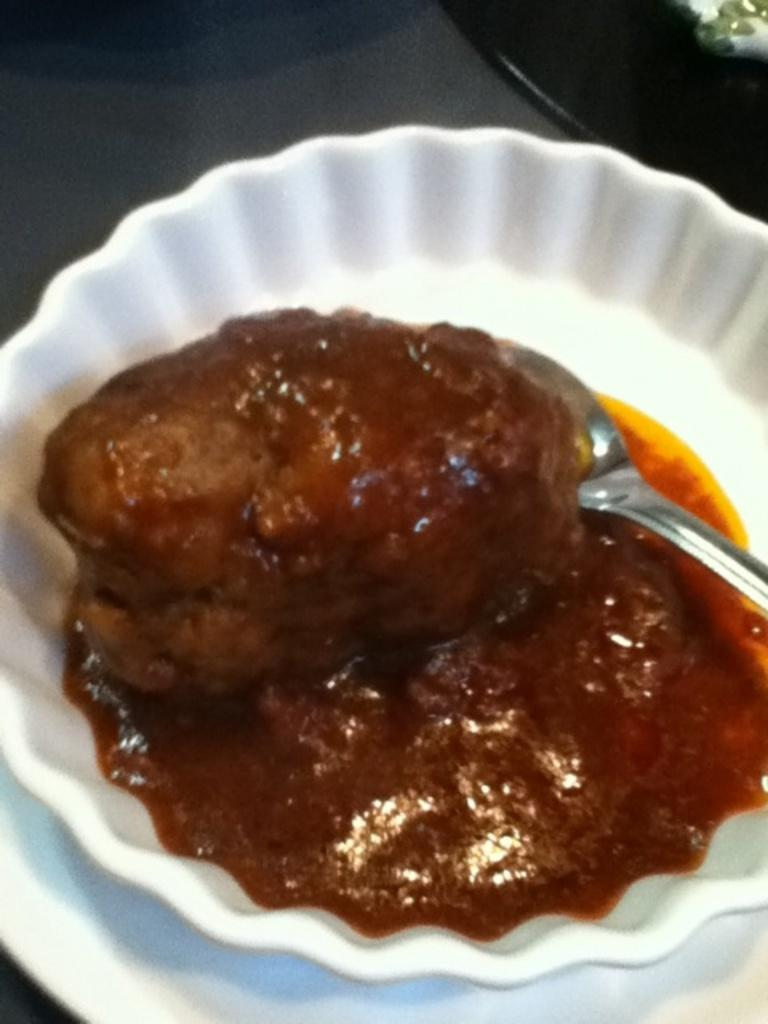What is on the plate in the image? There is a bowl on a plate in the image. What is inside the bowl? The bowl contains a food item. What utensil is present in the image? There is a spoon in the image. Can you describe the object in the top right corner of the image? Unfortunately, the facts provided do not give enough information to describe the object in the top right corner of the image. How does the detail in the image rub against the hammer? There is no detail rubbing against a hammer in the image, as the facts provided do not mention a hammer or any rubbing action. 